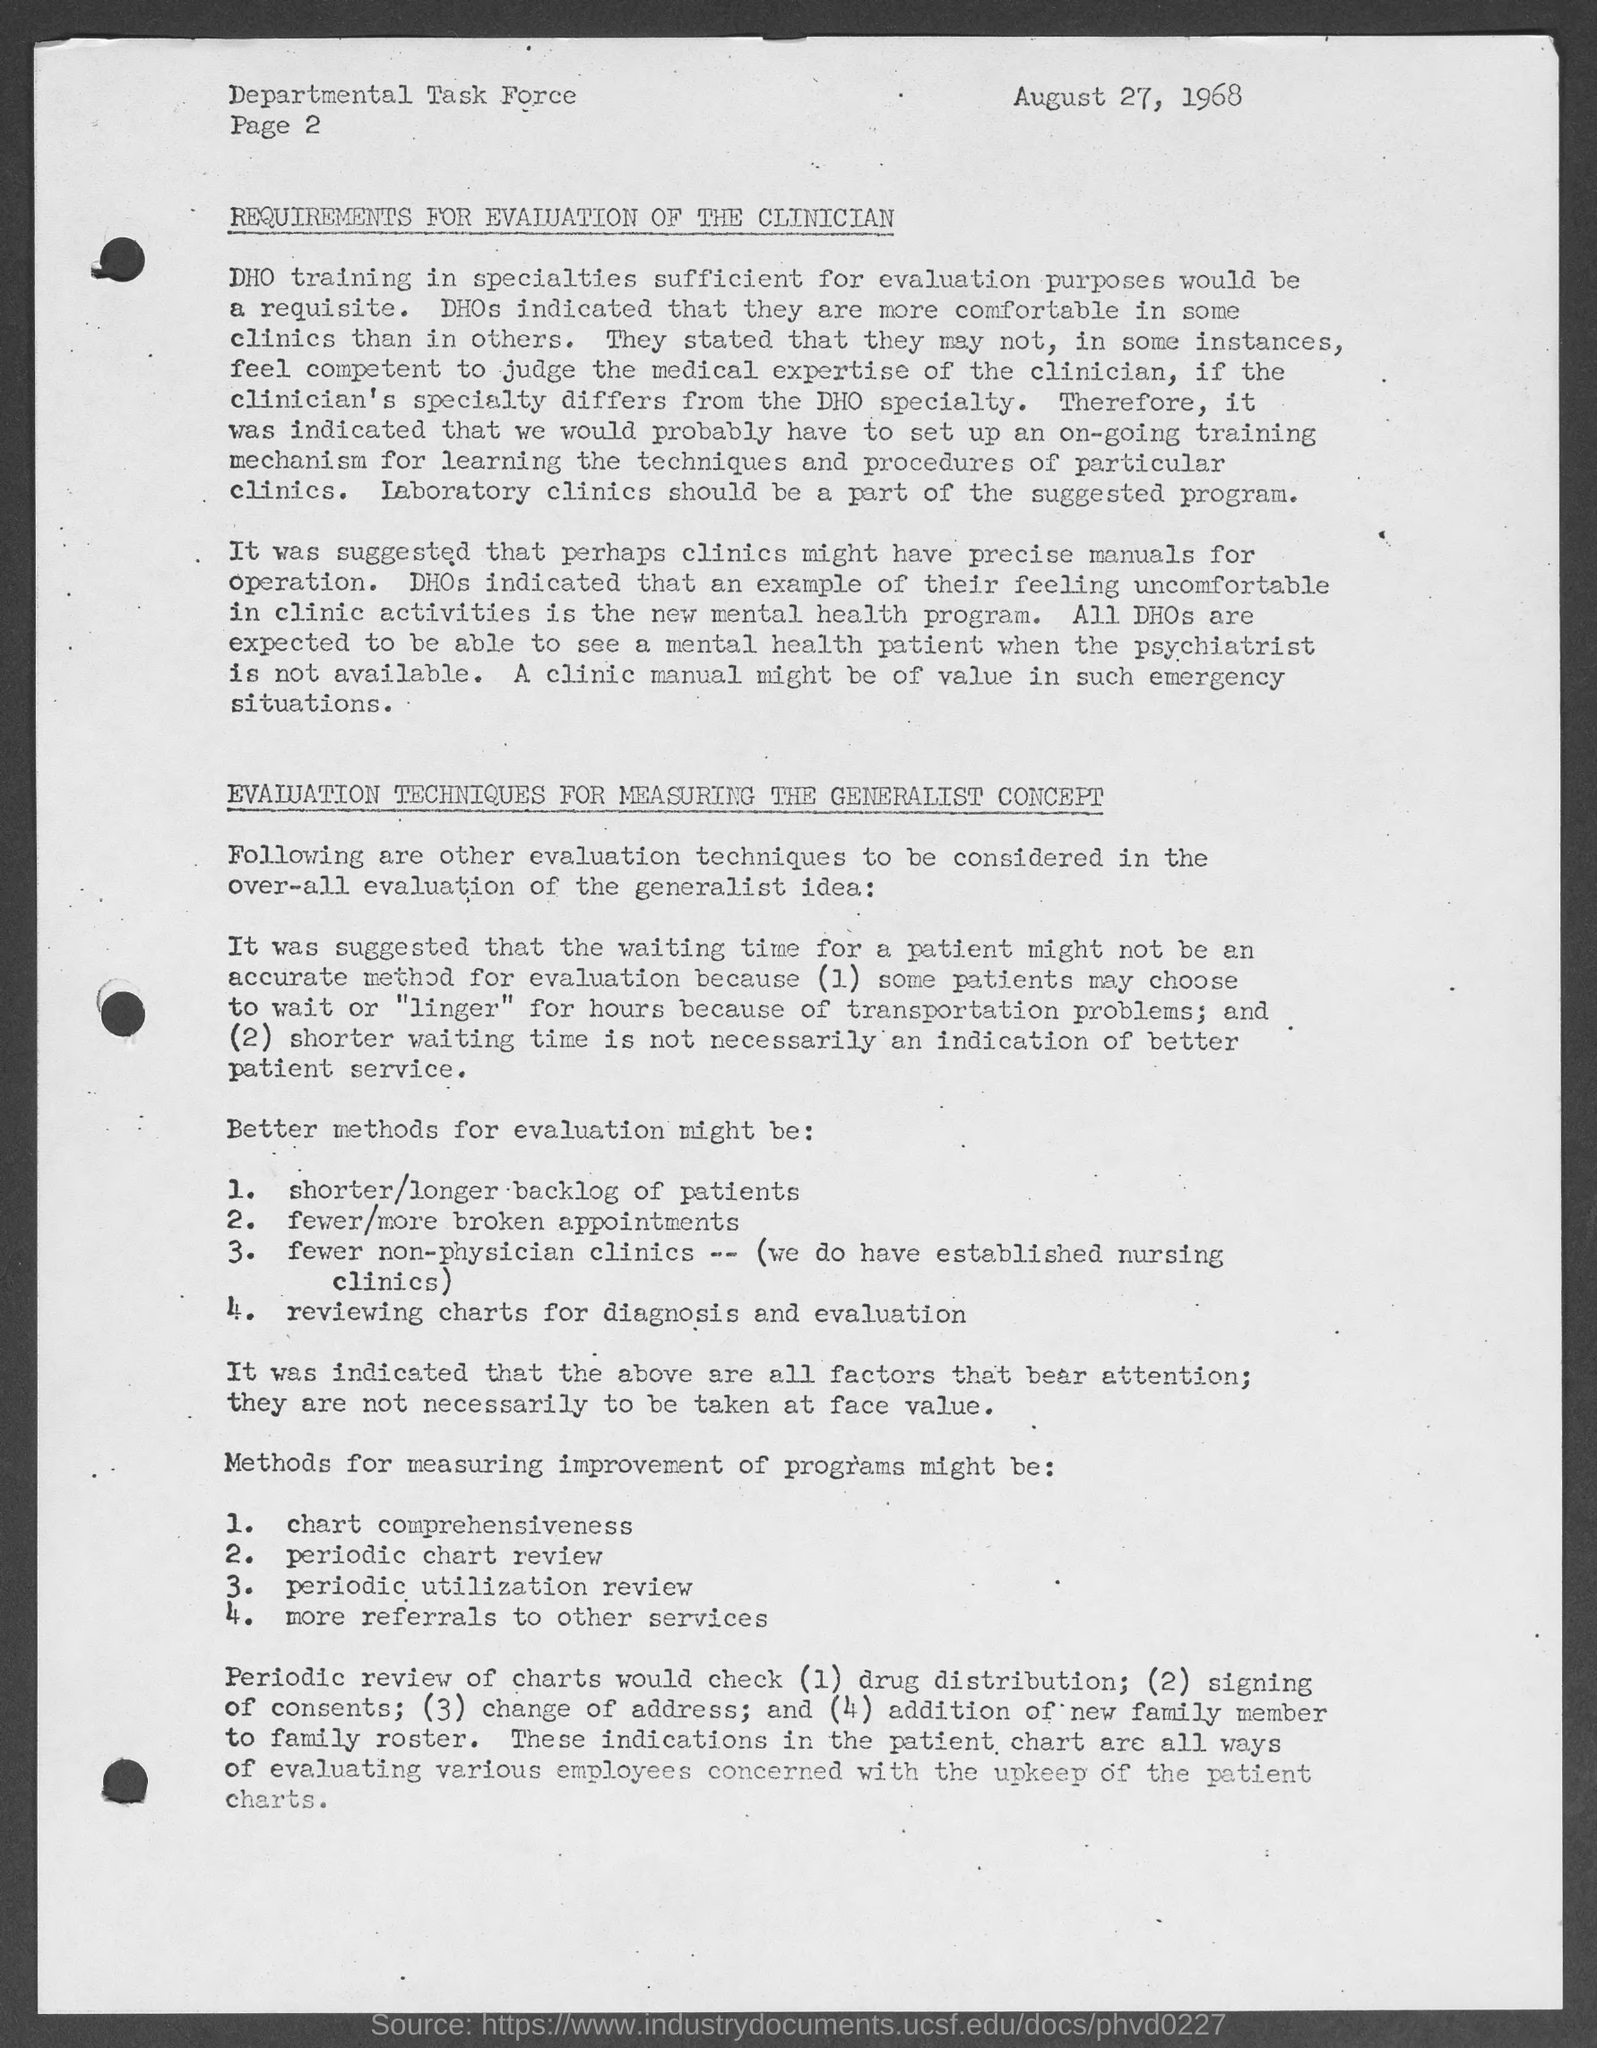What is the date mentioned in the document?
Keep it short and to the point. AUGUST 27, 1968. What is the Page Number?
Your answer should be very brief. 2. 